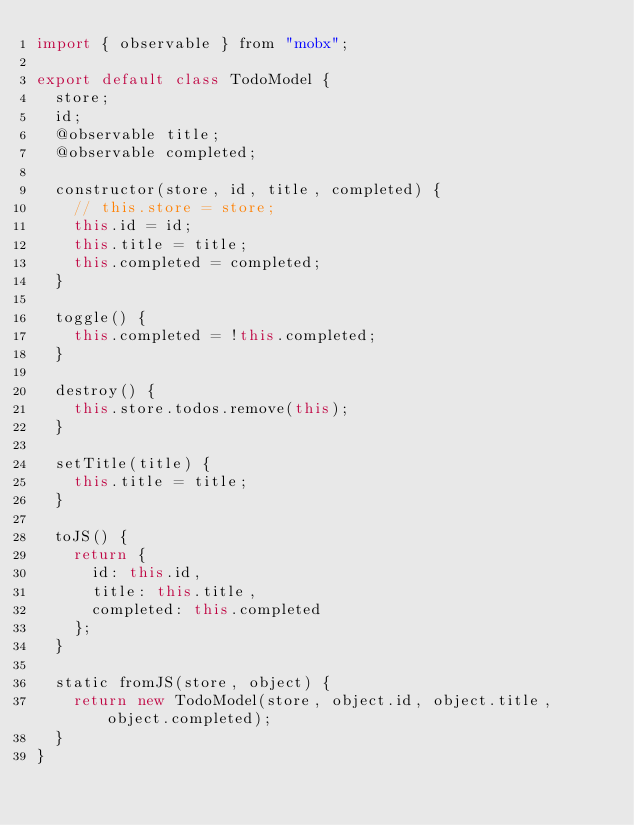<code> <loc_0><loc_0><loc_500><loc_500><_JavaScript_>import { observable } from "mobx";

export default class TodoModel {
  store;
  id;
  @observable title;
  @observable completed;

  constructor(store, id, title, completed) {
    // this.store = store;
    this.id = id;
    this.title = title;
    this.completed = completed;
  }

  toggle() {
    this.completed = !this.completed;
  }

  destroy() {
    this.store.todos.remove(this);
  }

  setTitle(title) {
    this.title = title;
  }

  toJS() {
    return {
      id: this.id,
      title: this.title,
      completed: this.completed
    };
  }

  static fromJS(store, object) {
    return new TodoModel(store, object.id, object.title, object.completed);
  }
}
</code> 